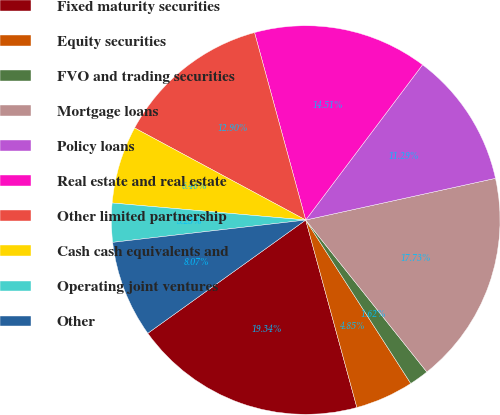Convert chart to OTSL. <chart><loc_0><loc_0><loc_500><loc_500><pie_chart><fcel>Fixed maturity securities<fcel>Equity securities<fcel>FVO and trading securities<fcel>Mortgage loans<fcel>Policy loans<fcel>Real estate and real estate<fcel>Other limited partnership<fcel>Cash cash equivalents and<fcel>Operating joint ventures<fcel>Other<nl><fcel>19.34%<fcel>4.85%<fcel>1.62%<fcel>17.73%<fcel>11.29%<fcel>14.51%<fcel>12.9%<fcel>6.46%<fcel>3.23%<fcel>8.07%<nl></chart> 